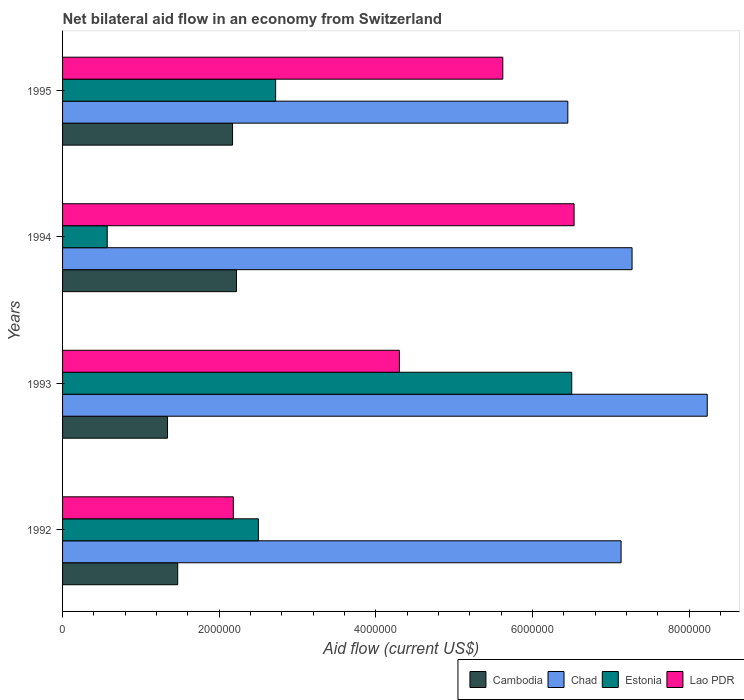How many different coloured bars are there?
Offer a terse response. 4. How many groups of bars are there?
Make the answer very short. 4. How many bars are there on the 4th tick from the top?
Your answer should be compact. 4. What is the label of the 3rd group of bars from the top?
Offer a terse response. 1993. In how many cases, is the number of bars for a given year not equal to the number of legend labels?
Your answer should be compact. 0. What is the net bilateral aid flow in Lao PDR in 1993?
Make the answer very short. 4.30e+06. Across all years, what is the maximum net bilateral aid flow in Estonia?
Give a very brief answer. 6.50e+06. Across all years, what is the minimum net bilateral aid flow in Chad?
Keep it short and to the point. 6.45e+06. In which year was the net bilateral aid flow in Lao PDR maximum?
Your response must be concise. 1994. In which year was the net bilateral aid flow in Estonia minimum?
Give a very brief answer. 1994. What is the total net bilateral aid flow in Estonia in the graph?
Provide a succinct answer. 1.23e+07. What is the difference between the net bilateral aid flow in Estonia in 1992 and that in 1995?
Your response must be concise. -2.20e+05. What is the difference between the net bilateral aid flow in Lao PDR in 1994 and the net bilateral aid flow in Chad in 1993?
Offer a very short reply. -1.70e+06. What is the average net bilateral aid flow in Chad per year?
Give a very brief answer. 7.27e+06. In the year 1995, what is the difference between the net bilateral aid flow in Chad and net bilateral aid flow in Cambodia?
Your answer should be very brief. 4.28e+06. In how many years, is the net bilateral aid flow in Lao PDR greater than 5200000 US$?
Your answer should be very brief. 2. What is the ratio of the net bilateral aid flow in Estonia in 1994 to that in 1995?
Offer a terse response. 0.21. Is the net bilateral aid flow in Chad in 1992 less than that in 1995?
Ensure brevity in your answer.  No. Is the difference between the net bilateral aid flow in Chad in 1992 and 1994 greater than the difference between the net bilateral aid flow in Cambodia in 1992 and 1994?
Your response must be concise. Yes. What is the difference between the highest and the second highest net bilateral aid flow in Estonia?
Your answer should be very brief. 3.78e+06. What is the difference between the highest and the lowest net bilateral aid flow in Cambodia?
Give a very brief answer. 8.80e+05. In how many years, is the net bilateral aid flow in Cambodia greater than the average net bilateral aid flow in Cambodia taken over all years?
Your answer should be compact. 2. What does the 2nd bar from the top in 1993 represents?
Make the answer very short. Estonia. What does the 2nd bar from the bottom in 1995 represents?
Provide a short and direct response. Chad. What is the difference between two consecutive major ticks on the X-axis?
Offer a terse response. 2.00e+06. Does the graph contain grids?
Your response must be concise. No. What is the title of the graph?
Provide a short and direct response. Net bilateral aid flow in an economy from Switzerland. Does "Andorra" appear as one of the legend labels in the graph?
Provide a succinct answer. No. What is the label or title of the X-axis?
Provide a succinct answer. Aid flow (current US$). What is the Aid flow (current US$) in Cambodia in 1992?
Make the answer very short. 1.47e+06. What is the Aid flow (current US$) of Chad in 1992?
Provide a succinct answer. 7.13e+06. What is the Aid flow (current US$) in Estonia in 1992?
Give a very brief answer. 2.50e+06. What is the Aid flow (current US$) in Lao PDR in 1992?
Ensure brevity in your answer.  2.18e+06. What is the Aid flow (current US$) in Cambodia in 1993?
Provide a succinct answer. 1.34e+06. What is the Aid flow (current US$) of Chad in 1993?
Your answer should be very brief. 8.23e+06. What is the Aid flow (current US$) in Estonia in 1993?
Offer a terse response. 6.50e+06. What is the Aid flow (current US$) in Lao PDR in 1993?
Offer a very short reply. 4.30e+06. What is the Aid flow (current US$) in Cambodia in 1994?
Ensure brevity in your answer.  2.22e+06. What is the Aid flow (current US$) of Chad in 1994?
Make the answer very short. 7.27e+06. What is the Aid flow (current US$) of Estonia in 1994?
Ensure brevity in your answer.  5.70e+05. What is the Aid flow (current US$) in Lao PDR in 1994?
Provide a succinct answer. 6.53e+06. What is the Aid flow (current US$) in Cambodia in 1995?
Your response must be concise. 2.17e+06. What is the Aid flow (current US$) in Chad in 1995?
Your answer should be very brief. 6.45e+06. What is the Aid flow (current US$) in Estonia in 1995?
Give a very brief answer. 2.72e+06. What is the Aid flow (current US$) of Lao PDR in 1995?
Keep it short and to the point. 5.62e+06. Across all years, what is the maximum Aid flow (current US$) of Cambodia?
Make the answer very short. 2.22e+06. Across all years, what is the maximum Aid flow (current US$) of Chad?
Give a very brief answer. 8.23e+06. Across all years, what is the maximum Aid flow (current US$) in Estonia?
Your answer should be very brief. 6.50e+06. Across all years, what is the maximum Aid flow (current US$) in Lao PDR?
Offer a terse response. 6.53e+06. Across all years, what is the minimum Aid flow (current US$) of Cambodia?
Your response must be concise. 1.34e+06. Across all years, what is the minimum Aid flow (current US$) of Chad?
Keep it short and to the point. 6.45e+06. Across all years, what is the minimum Aid flow (current US$) in Estonia?
Provide a succinct answer. 5.70e+05. Across all years, what is the minimum Aid flow (current US$) of Lao PDR?
Your answer should be compact. 2.18e+06. What is the total Aid flow (current US$) in Cambodia in the graph?
Offer a terse response. 7.20e+06. What is the total Aid flow (current US$) of Chad in the graph?
Your answer should be compact. 2.91e+07. What is the total Aid flow (current US$) of Estonia in the graph?
Make the answer very short. 1.23e+07. What is the total Aid flow (current US$) of Lao PDR in the graph?
Ensure brevity in your answer.  1.86e+07. What is the difference between the Aid flow (current US$) in Chad in 1992 and that in 1993?
Provide a short and direct response. -1.10e+06. What is the difference between the Aid flow (current US$) in Estonia in 1992 and that in 1993?
Keep it short and to the point. -4.00e+06. What is the difference between the Aid flow (current US$) in Lao PDR in 1992 and that in 1993?
Make the answer very short. -2.12e+06. What is the difference between the Aid flow (current US$) in Cambodia in 1992 and that in 1994?
Offer a terse response. -7.50e+05. What is the difference between the Aid flow (current US$) of Estonia in 1992 and that in 1994?
Give a very brief answer. 1.93e+06. What is the difference between the Aid flow (current US$) in Lao PDR in 1992 and that in 1994?
Offer a terse response. -4.35e+06. What is the difference between the Aid flow (current US$) in Cambodia in 1992 and that in 1995?
Keep it short and to the point. -7.00e+05. What is the difference between the Aid flow (current US$) of Chad in 1992 and that in 1995?
Ensure brevity in your answer.  6.80e+05. What is the difference between the Aid flow (current US$) in Lao PDR in 1992 and that in 1995?
Provide a short and direct response. -3.44e+06. What is the difference between the Aid flow (current US$) of Cambodia in 1993 and that in 1994?
Keep it short and to the point. -8.80e+05. What is the difference between the Aid flow (current US$) in Chad in 1993 and that in 1994?
Your answer should be very brief. 9.60e+05. What is the difference between the Aid flow (current US$) of Estonia in 1993 and that in 1994?
Make the answer very short. 5.93e+06. What is the difference between the Aid flow (current US$) in Lao PDR in 1993 and that in 1994?
Keep it short and to the point. -2.23e+06. What is the difference between the Aid flow (current US$) of Cambodia in 1993 and that in 1995?
Your answer should be compact. -8.30e+05. What is the difference between the Aid flow (current US$) of Chad in 1993 and that in 1995?
Ensure brevity in your answer.  1.78e+06. What is the difference between the Aid flow (current US$) of Estonia in 1993 and that in 1995?
Ensure brevity in your answer.  3.78e+06. What is the difference between the Aid flow (current US$) in Lao PDR in 1993 and that in 1995?
Your answer should be compact. -1.32e+06. What is the difference between the Aid flow (current US$) of Chad in 1994 and that in 1995?
Make the answer very short. 8.20e+05. What is the difference between the Aid flow (current US$) in Estonia in 1994 and that in 1995?
Ensure brevity in your answer.  -2.15e+06. What is the difference between the Aid flow (current US$) in Lao PDR in 1994 and that in 1995?
Provide a short and direct response. 9.10e+05. What is the difference between the Aid flow (current US$) of Cambodia in 1992 and the Aid flow (current US$) of Chad in 1993?
Provide a succinct answer. -6.76e+06. What is the difference between the Aid flow (current US$) in Cambodia in 1992 and the Aid flow (current US$) in Estonia in 1993?
Make the answer very short. -5.03e+06. What is the difference between the Aid flow (current US$) in Cambodia in 1992 and the Aid flow (current US$) in Lao PDR in 1993?
Keep it short and to the point. -2.83e+06. What is the difference between the Aid flow (current US$) of Chad in 1992 and the Aid flow (current US$) of Estonia in 1993?
Make the answer very short. 6.30e+05. What is the difference between the Aid flow (current US$) of Chad in 1992 and the Aid flow (current US$) of Lao PDR in 1993?
Your answer should be compact. 2.83e+06. What is the difference between the Aid flow (current US$) in Estonia in 1992 and the Aid flow (current US$) in Lao PDR in 1993?
Ensure brevity in your answer.  -1.80e+06. What is the difference between the Aid flow (current US$) in Cambodia in 1992 and the Aid flow (current US$) in Chad in 1994?
Make the answer very short. -5.80e+06. What is the difference between the Aid flow (current US$) of Cambodia in 1992 and the Aid flow (current US$) of Lao PDR in 1994?
Your answer should be compact. -5.06e+06. What is the difference between the Aid flow (current US$) of Chad in 1992 and the Aid flow (current US$) of Estonia in 1994?
Give a very brief answer. 6.56e+06. What is the difference between the Aid flow (current US$) of Chad in 1992 and the Aid flow (current US$) of Lao PDR in 1994?
Your answer should be very brief. 6.00e+05. What is the difference between the Aid flow (current US$) of Estonia in 1992 and the Aid flow (current US$) of Lao PDR in 1994?
Provide a succinct answer. -4.03e+06. What is the difference between the Aid flow (current US$) of Cambodia in 1992 and the Aid flow (current US$) of Chad in 1995?
Offer a very short reply. -4.98e+06. What is the difference between the Aid flow (current US$) of Cambodia in 1992 and the Aid flow (current US$) of Estonia in 1995?
Your answer should be compact. -1.25e+06. What is the difference between the Aid flow (current US$) of Cambodia in 1992 and the Aid flow (current US$) of Lao PDR in 1995?
Provide a short and direct response. -4.15e+06. What is the difference between the Aid flow (current US$) of Chad in 1992 and the Aid flow (current US$) of Estonia in 1995?
Your answer should be compact. 4.41e+06. What is the difference between the Aid flow (current US$) in Chad in 1992 and the Aid flow (current US$) in Lao PDR in 1995?
Provide a short and direct response. 1.51e+06. What is the difference between the Aid flow (current US$) of Estonia in 1992 and the Aid flow (current US$) of Lao PDR in 1995?
Your answer should be compact. -3.12e+06. What is the difference between the Aid flow (current US$) in Cambodia in 1993 and the Aid flow (current US$) in Chad in 1994?
Ensure brevity in your answer.  -5.93e+06. What is the difference between the Aid flow (current US$) in Cambodia in 1993 and the Aid flow (current US$) in Estonia in 1994?
Offer a very short reply. 7.70e+05. What is the difference between the Aid flow (current US$) of Cambodia in 1993 and the Aid flow (current US$) of Lao PDR in 1994?
Your answer should be compact. -5.19e+06. What is the difference between the Aid flow (current US$) in Chad in 1993 and the Aid flow (current US$) in Estonia in 1994?
Provide a short and direct response. 7.66e+06. What is the difference between the Aid flow (current US$) of Chad in 1993 and the Aid flow (current US$) of Lao PDR in 1994?
Your answer should be very brief. 1.70e+06. What is the difference between the Aid flow (current US$) of Estonia in 1993 and the Aid flow (current US$) of Lao PDR in 1994?
Your answer should be very brief. -3.00e+04. What is the difference between the Aid flow (current US$) of Cambodia in 1993 and the Aid flow (current US$) of Chad in 1995?
Your response must be concise. -5.11e+06. What is the difference between the Aid flow (current US$) of Cambodia in 1993 and the Aid flow (current US$) of Estonia in 1995?
Give a very brief answer. -1.38e+06. What is the difference between the Aid flow (current US$) in Cambodia in 1993 and the Aid flow (current US$) in Lao PDR in 1995?
Give a very brief answer. -4.28e+06. What is the difference between the Aid flow (current US$) of Chad in 1993 and the Aid flow (current US$) of Estonia in 1995?
Your answer should be compact. 5.51e+06. What is the difference between the Aid flow (current US$) of Chad in 1993 and the Aid flow (current US$) of Lao PDR in 1995?
Provide a succinct answer. 2.61e+06. What is the difference between the Aid flow (current US$) of Estonia in 1993 and the Aid flow (current US$) of Lao PDR in 1995?
Keep it short and to the point. 8.80e+05. What is the difference between the Aid flow (current US$) of Cambodia in 1994 and the Aid flow (current US$) of Chad in 1995?
Make the answer very short. -4.23e+06. What is the difference between the Aid flow (current US$) in Cambodia in 1994 and the Aid flow (current US$) in Estonia in 1995?
Provide a succinct answer. -5.00e+05. What is the difference between the Aid flow (current US$) in Cambodia in 1994 and the Aid flow (current US$) in Lao PDR in 1995?
Provide a succinct answer. -3.40e+06. What is the difference between the Aid flow (current US$) of Chad in 1994 and the Aid flow (current US$) of Estonia in 1995?
Provide a short and direct response. 4.55e+06. What is the difference between the Aid flow (current US$) in Chad in 1994 and the Aid flow (current US$) in Lao PDR in 1995?
Offer a very short reply. 1.65e+06. What is the difference between the Aid flow (current US$) of Estonia in 1994 and the Aid flow (current US$) of Lao PDR in 1995?
Your answer should be compact. -5.05e+06. What is the average Aid flow (current US$) of Cambodia per year?
Your answer should be very brief. 1.80e+06. What is the average Aid flow (current US$) in Chad per year?
Your answer should be compact. 7.27e+06. What is the average Aid flow (current US$) of Estonia per year?
Your answer should be compact. 3.07e+06. What is the average Aid flow (current US$) in Lao PDR per year?
Offer a very short reply. 4.66e+06. In the year 1992, what is the difference between the Aid flow (current US$) in Cambodia and Aid flow (current US$) in Chad?
Your response must be concise. -5.66e+06. In the year 1992, what is the difference between the Aid flow (current US$) in Cambodia and Aid flow (current US$) in Estonia?
Keep it short and to the point. -1.03e+06. In the year 1992, what is the difference between the Aid flow (current US$) of Cambodia and Aid flow (current US$) of Lao PDR?
Offer a very short reply. -7.10e+05. In the year 1992, what is the difference between the Aid flow (current US$) of Chad and Aid flow (current US$) of Estonia?
Keep it short and to the point. 4.63e+06. In the year 1992, what is the difference between the Aid flow (current US$) in Chad and Aid flow (current US$) in Lao PDR?
Provide a succinct answer. 4.95e+06. In the year 1993, what is the difference between the Aid flow (current US$) in Cambodia and Aid flow (current US$) in Chad?
Ensure brevity in your answer.  -6.89e+06. In the year 1993, what is the difference between the Aid flow (current US$) of Cambodia and Aid flow (current US$) of Estonia?
Make the answer very short. -5.16e+06. In the year 1993, what is the difference between the Aid flow (current US$) of Cambodia and Aid flow (current US$) of Lao PDR?
Your answer should be very brief. -2.96e+06. In the year 1993, what is the difference between the Aid flow (current US$) of Chad and Aid flow (current US$) of Estonia?
Give a very brief answer. 1.73e+06. In the year 1993, what is the difference between the Aid flow (current US$) in Chad and Aid flow (current US$) in Lao PDR?
Provide a succinct answer. 3.93e+06. In the year 1993, what is the difference between the Aid flow (current US$) in Estonia and Aid flow (current US$) in Lao PDR?
Give a very brief answer. 2.20e+06. In the year 1994, what is the difference between the Aid flow (current US$) in Cambodia and Aid flow (current US$) in Chad?
Ensure brevity in your answer.  -5.05e+06. In the year 1994, what is the difference between the Aid flow (current US$) in Cambodia and Aid flow (current US$) in Estonia?
Offer a terse response. 1.65e+06. In the year 1994, what is the difference between the Aid flow (current US$) of Cambodia and Aid flow (current US$) of Lao PDR?
Provide a succinct answer. -4.31e+06. In the year 1994, what is the difference between the Aid flow (current US$) of Chad and Aid flow (current US$) of Estonia?
Offer a terse response. 6.70e+06. In the year 1994, what is the difference between the Aid flow (current US$) in Chad and Aid flow (current US$) in Lao PDR?
Offer a terse response. 7.40e+05. In the year 1994, what is the difference between the Aid flow (current US$) of Estonia and Aid flow (current US$) of Lao PDR?
Offer a very short reply. -5.96e+06. In the year 1995, what is the difference between the Aid flow (current US$) of Cambodia and Aid flow (current US$) of Chad?
Make the answer very short. -4.28e+06. In the year 1995, what is the difference between the Aid flow (current US$) in Cambodia and Aid flow (current US$) in Estonia?
Offer a very short reply. -5.50e+05. In the year 1995, what is the difference between the Aid flow (current US$) in Cambodia and Aid flow (current US$) in Lao PDR?
Your answer should be very brief. -3.45e+06. In the year 1995, what is the difference between the Aid flow (current US$) of Chad and Aid flow (current US$) of Estonia?
Give a very brief answer. 3.73e+06. In the year 1995, what is the difference between the Aid flow (current US$) of Chad and Aid flow (current US$) of Lao PDR?
Offer a terse response. 8.30e+05. In the year 1995, what is the difference between the Aid flow (current US$) in Estonia and Aid flow (current US$) in Lao PDR?
Your answer should be very brief. -2.90e+06. What is the ratio of the Aid flow (current US$) in Cambodia in 1992 to that in 1993?
Keep it short and to the point. 1.1. What is the ratio of the Aid flow (current US$) in Chad in 1992 to that in 1993?
Provide a succinct answer. 0.87. What is the ratio of the Aid flow (current US$) of Estonia in 1992 to that in 1993?
Make the answer very short. 0.38. What is the ratio of the Aid flow (current US$) in Lao PDR in 1992 to that in 1993?
Ensure brevity in your answer.  0.51. What is the ratio of the Aid flow (current US$) of Cambodia in 1992 to that in 1994?
Ensure brevity in your answer.  0.66. What is the ratio of the Aid flow (current US$) in Chad in 1992 to that in 1994?
Make the answer very short. 0.98. What is the ratio of the Aid flow (current US$) in Estonia in 1992 to that in 1994?
Offer a terse response. 4.39. What is the ratio of the Aid flow (current US$) in Lao PDR in 1992 to that in 1994?
Make the answer very short. 0.33. What is the ratio of the Aid flow (current US$) of Cambodia in 1992 to that in 1995?
Provide a succinct answer. 0.68. What is the ratio of the Aid flow (current US$) in Chad in 1992 to that in 1995?
Provide a short and direct response. 1.11. What is the ratio of the Aid flow (current US$) in Estonia in 1992 to that in 1995?
Your response must be concise. 0.92. What is the ratio of the Aid flow (current US$) in Lao PDR in 1992 to that in 1995?
Your response must be concise. 0.39. What is the ratio of the Aid flow (current US$) in Cambodia in 1993 to that in 1994?
Provide a succinct answer. 0.6. What is the ratio of the Aid flow (current US$) of Chad in 1993 to that in 1994?
Provide a succinct answer. 1.13. What is the ratio of the Aid flow (current US$) in Estonia in 1993 to that in 1994?
Your answer should be compact. 11.4. What is the ratio of the Aid flow (current US$) in Lao PDR in 1993 to that in 1994?
Your answer should be compact. 0.66. What is the ratio of the Aid flow (current US$) of Cambodia in 1993 to that in 1995?
Make the answer very short. 0.62. What is the ratio of the Aid flow (current US$) of Chad in 1993 to that in 1995?
Offer a terse response. 1.28. What is the ratio of the Aid flow (current US$) in Estonia in 1993 to that in 1995?
Make the answer very short. 2.39. What is the ratio of the Aid flow (current US$) in Lao PDR in 1993 to that in 1995?
Offer a terse response. 0.77. What is the ratio of the Aid flow (current US$) in Cambodia in 1994 to that in 1995?
Provide a short and direct response. 1.02. What is the ratio of the Aid flow (current US$) of Chad in 1994 to that in 1995?
Provide a short and direct response. 1.13. What is the ratio of the Aid flow (current US$) in Estonia in 1994 to that in 1995?
Make the answer very short. 0.21. What is the ratio of the Aid flow (current US$) in Lao PDR in 1994 to that in 1995?
Offer a terse response. 1.16. What is the difference between the highest and the second highest Aid flow (current US$) of Chad?
Keep it short and to the point. 9.60e+05. What is the difference between the highest and the second highest Aid flow (current US$) in Estonia?
Your answer should be compact. 3.78e+06. What is the difference between the highest and the second highest Aid flow (current US$) in Lao PDR?
Your answer should be compact. 9.10e+05. What is the difference between the highest and the lowest Aid flow (current US$) in Cambodia?
Your response must be concise. 8.80e+05. What is the difference between the highest and the lowest Aid flow (current US$) of Chad?
Give a very brief answer. 1.78e+06. What is the difference between the highest and the lowest Aid flow (current US$) in Estonia?
Offer a very short reply. 5.93e+06. What is the difference between the highest and the lowest Aid flow (current US$) in Lao PDR?
Offer a terse response. 4.35e+06. 